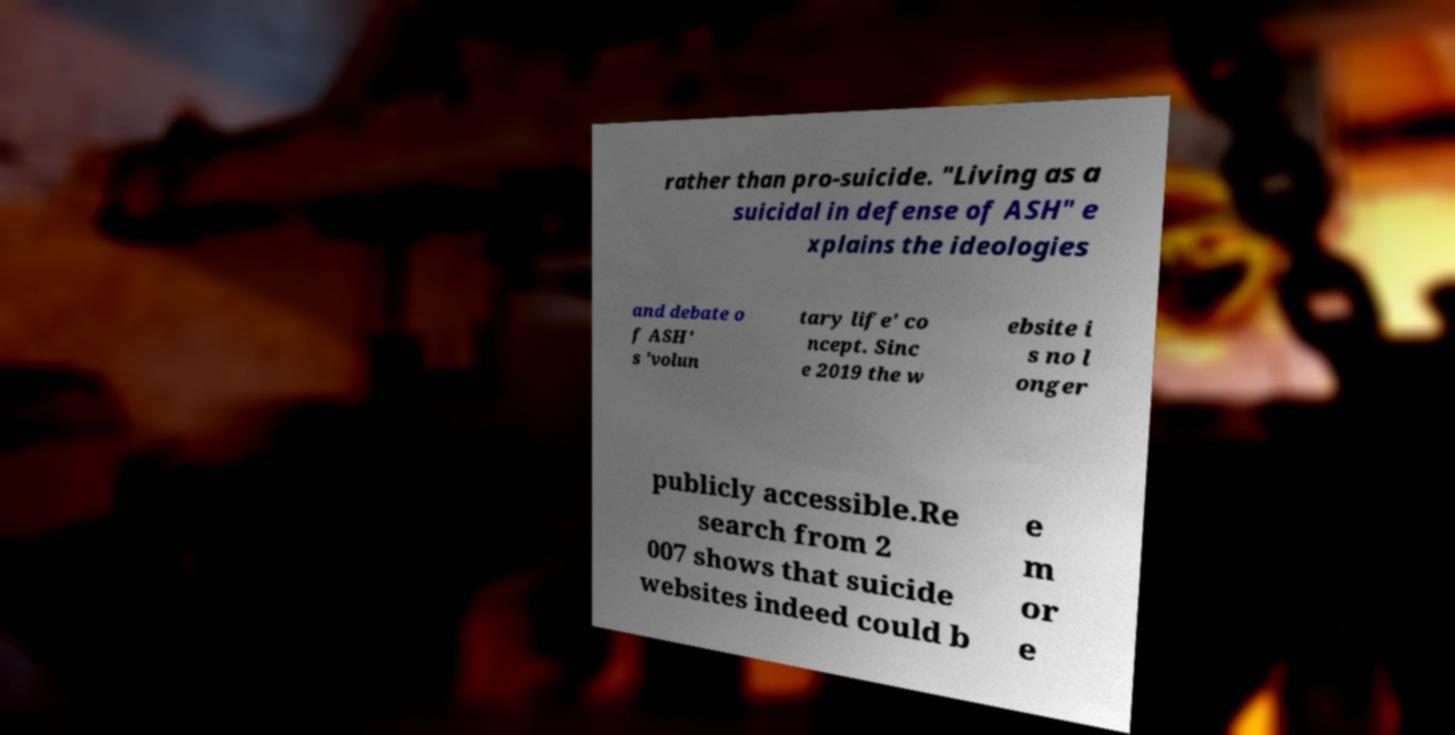For documentation purposes, I need the text within this image transcribed. Could you provide that? rather than pro-suicide. "Living as a suicidal in defense of ASH" e xplains the ideologies and debate o f ASH' s 'volun tary life' co ncept. Sinc e 2019 the w ebsite i s no l onger publicly accessible.Re search from 2 007 shows that suicide websites indeed could b e m or e 